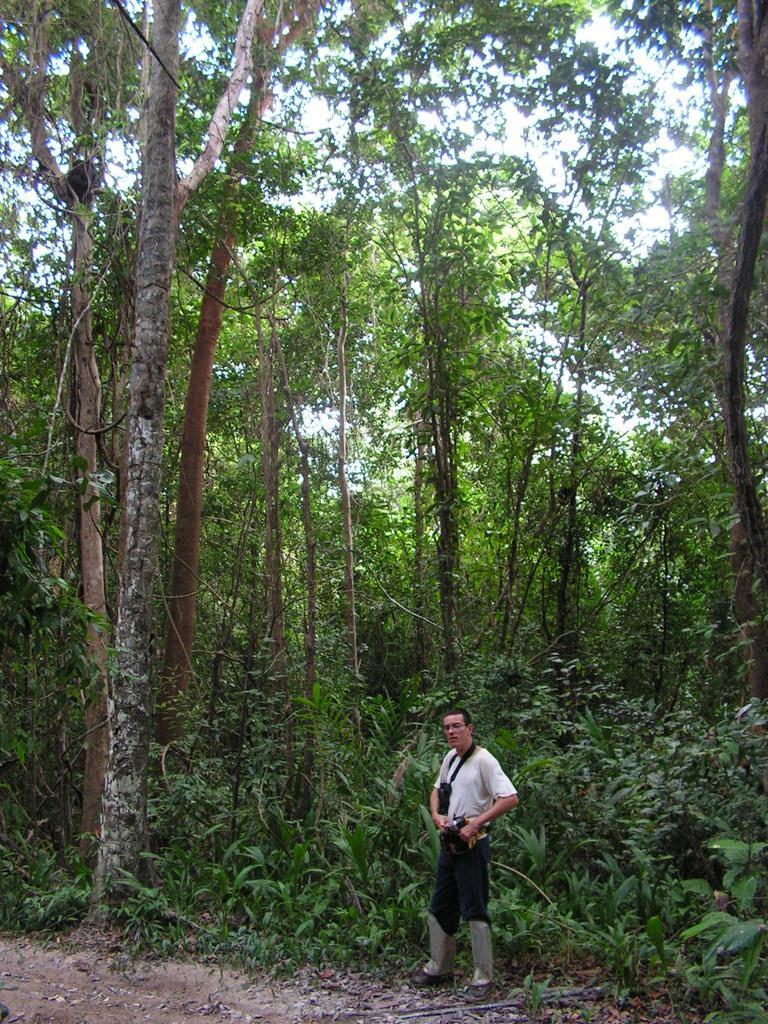Could you give a brief overview of what you see in this image? In this image we can see one man wearing one black object looks like a camera, standing and holding an object. There is one object in the tree, one object on the bottom left side of the image, one object looks like a wooden stick on the ground near the man, some dried leaves, some trees, plants and bushes on the ground. At the top there is the sky.  